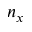Convert formula to latex. <formula><loc_0><loc_0><loc_500><loc_500>n _ { x }</formula> 